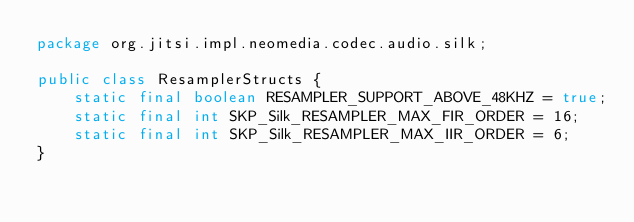<code> <loc_0><loc_0><loc_500><loc_500><_Java_>package org.jitsi.impl.neomedia.codec.audio.silk;

public class ResamplerStructs {
    static final boolean RESAMPLER_SUPPORT_ABOVE_48KHZ = true;
    static final int SKP_Silk_RESAMPLER_MAX_FIR_ORDER = 16;
    static final int SKP_Silk_RESAMPLER_MAX_IIR_ORDER = 6;
}
</code> 